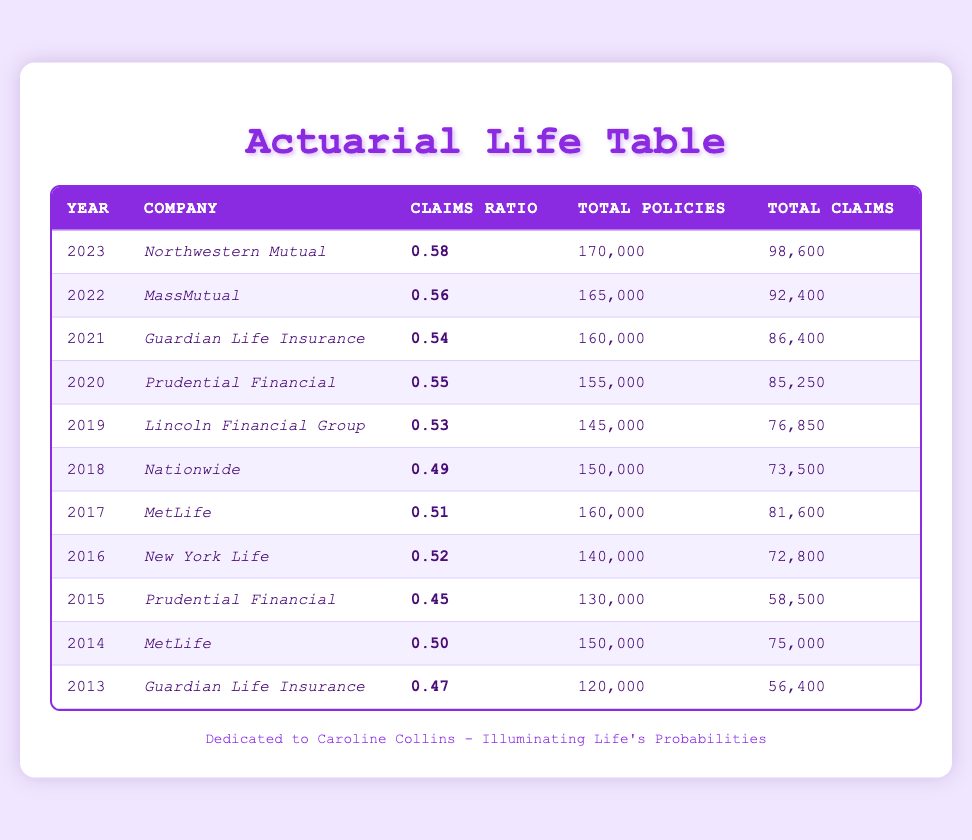What was the claims ratio for Prudential Financial in 2020? According to the table, Prudential Financial's claims ratio in 2020 is stated as 0.55.
Answer: 0.55 Which company had the highest claims ratio in 2023? The table shows that Northwestern Mutual had the highest claims ratio in 2023, which is 0.58.
Answer: Northwestern Mutual What is the average claims ratio over the last decade from 2013 to 2022? To calculate the average claims ratio, add all the claims ratios from the years 2013 to 2022 (0.47 + 0.50 + 0.45 + 0.52 + 0.51 + 0.49 + 0.53 + 0.55 + 0.54 + 0.56 = 5.57), then divide by the number of years (10). The average is 5.57 / 10 = 0.557.
Answer: 0.557 Was there a year when Guardian Life Insurance had a claims ratio below 0.50? According to the table, Guardian Life Insurance had claims ratios of 0.47 in 2013. Therefore, there was indeed a year when their claims ratio was below 0.50.
Answer: Yes In which year did MetLife report a claims ratio greater than 0.50? The data indicates that MetLife reported a claims ratio greater than 0.50 in 2017 (0.51) and in 2014 (0.50). However, only the year 2017 had a claims ratio of over 0.50.
Answer: 2017 What is the total number of policies across all companies in 2021? By consulting the table, the total number of policies for the year 2021 is 160,000 (Guardian Life Insurance). Since only one entry exists for this year, the total remains 160,000.
Answer: 160,000 Which company had a claims ratio increase from 2014 to 2017? By analyzing the claims ratios, MetLife's claims ratio increased from 0.50 in 2014 to 0.51 in 2017. Thus, MetLife is the company that experienced this increase.
Answer: MetLife How many total claims were filed by Nationwide in 2018? The table specifies that Nationwide filed a total of 73,500 claims in 2018.
Answer: 73,500 Why did the claims ratio for Prudential Financial increase from 2015 to 2020? Examining the table, Prudential Financial’s claims ratio improved from 0.45 in 2015 to 0.55 in 2020, indicating a better performance regarding claims against policies within that time frame. The increase may be attributed to changes in company policies, underwriting criteria, or overall market conditions.
Answer: Improving claims performance 